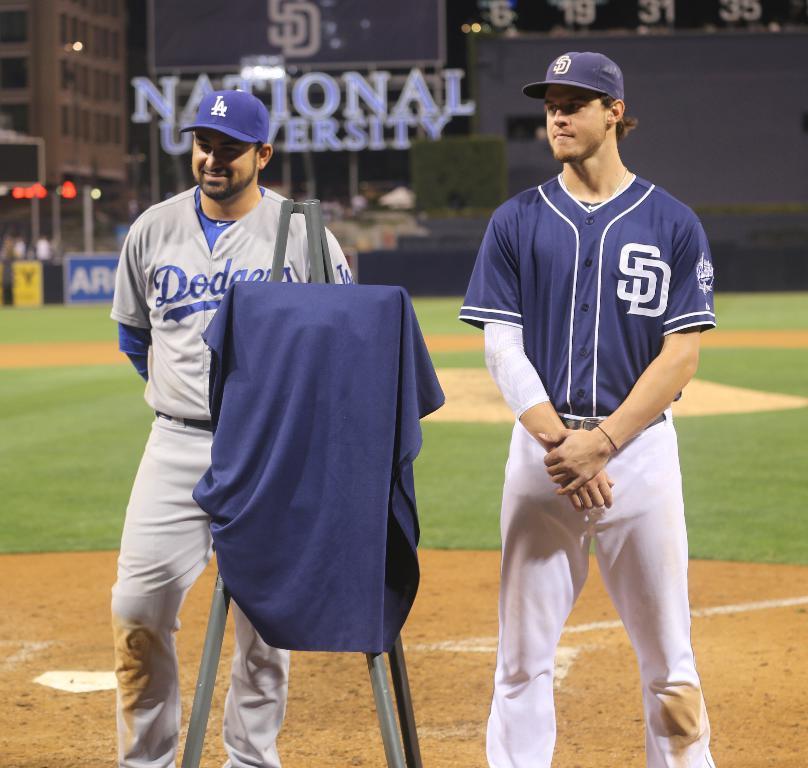What teams are these?
Provide a short and direct response. Dodgers. Where they played?
Your answer should be compact. National university. 